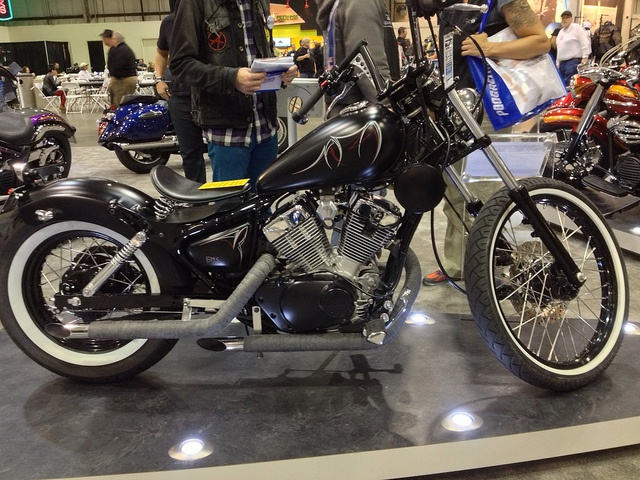Describe the objects in this image and their specific colors. I can see motorcycle in salmon, black, gray, and darkgray tones, people in salmon, black, gray, navy, and darkgray tones, motorcycle in salmon, black, gray, maroon, and darkgray tones, people in salmon, black, gray, and tan tones, and people in salmon, gray, and black tones in this image. 